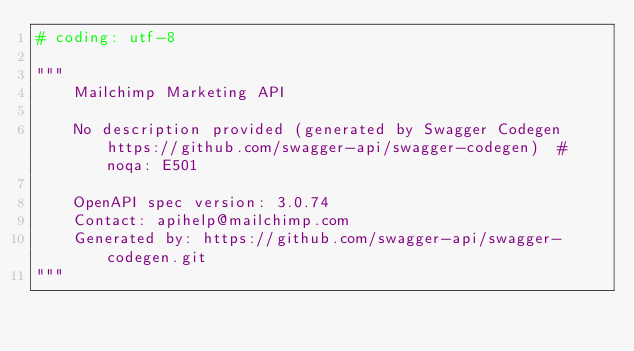Convert code to text. <code><loc_0><loc_0><loc_500><loc_500><_Python_># coding: utf-8

"""
    Mailchimp Marketing API

    No description provided (generated by Swagger Codegen https://github.com/swagger-api/swagger-codegen)  # noqa: E501

    OpenAPI spec version: 3.0.74
    Contact: apihelp@mailchimp.com
    Generated by: https://github.com/swagger-api/swagger-codegen.git
"""

</code> 